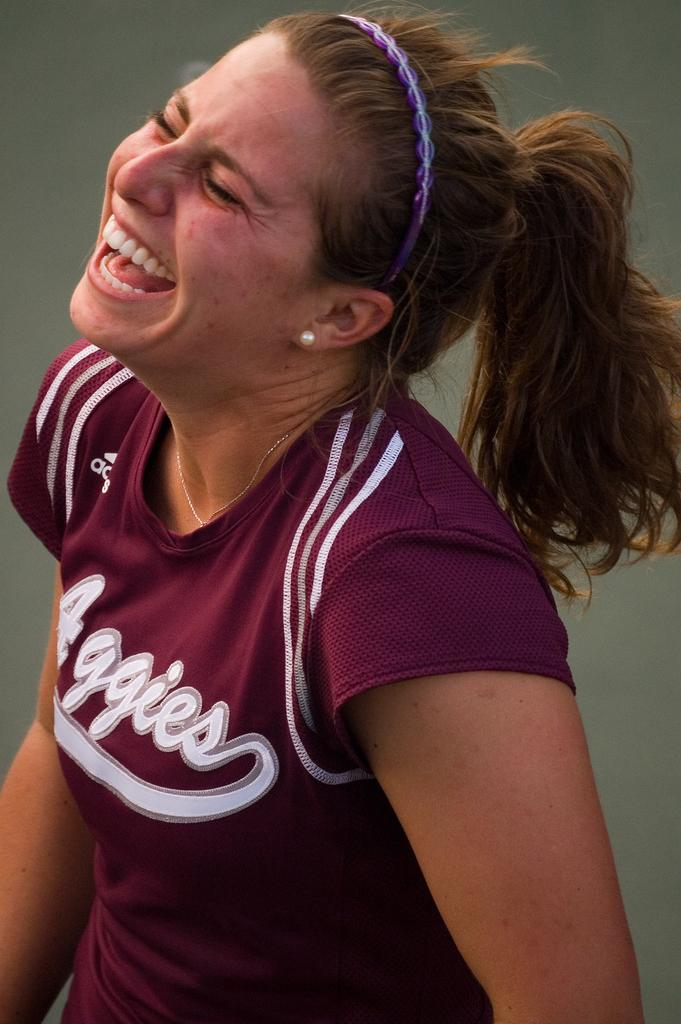What is present in the image? There is a person in the image. Can you describe the person's attire? The person is wearing clothes. What type of transport is visible in the image? There is no transport visible in the image; it only features a person wearing clothes. What kind of building can be seen in the background of the image? There is no building present in the image; it only features a person wearing clothes. 